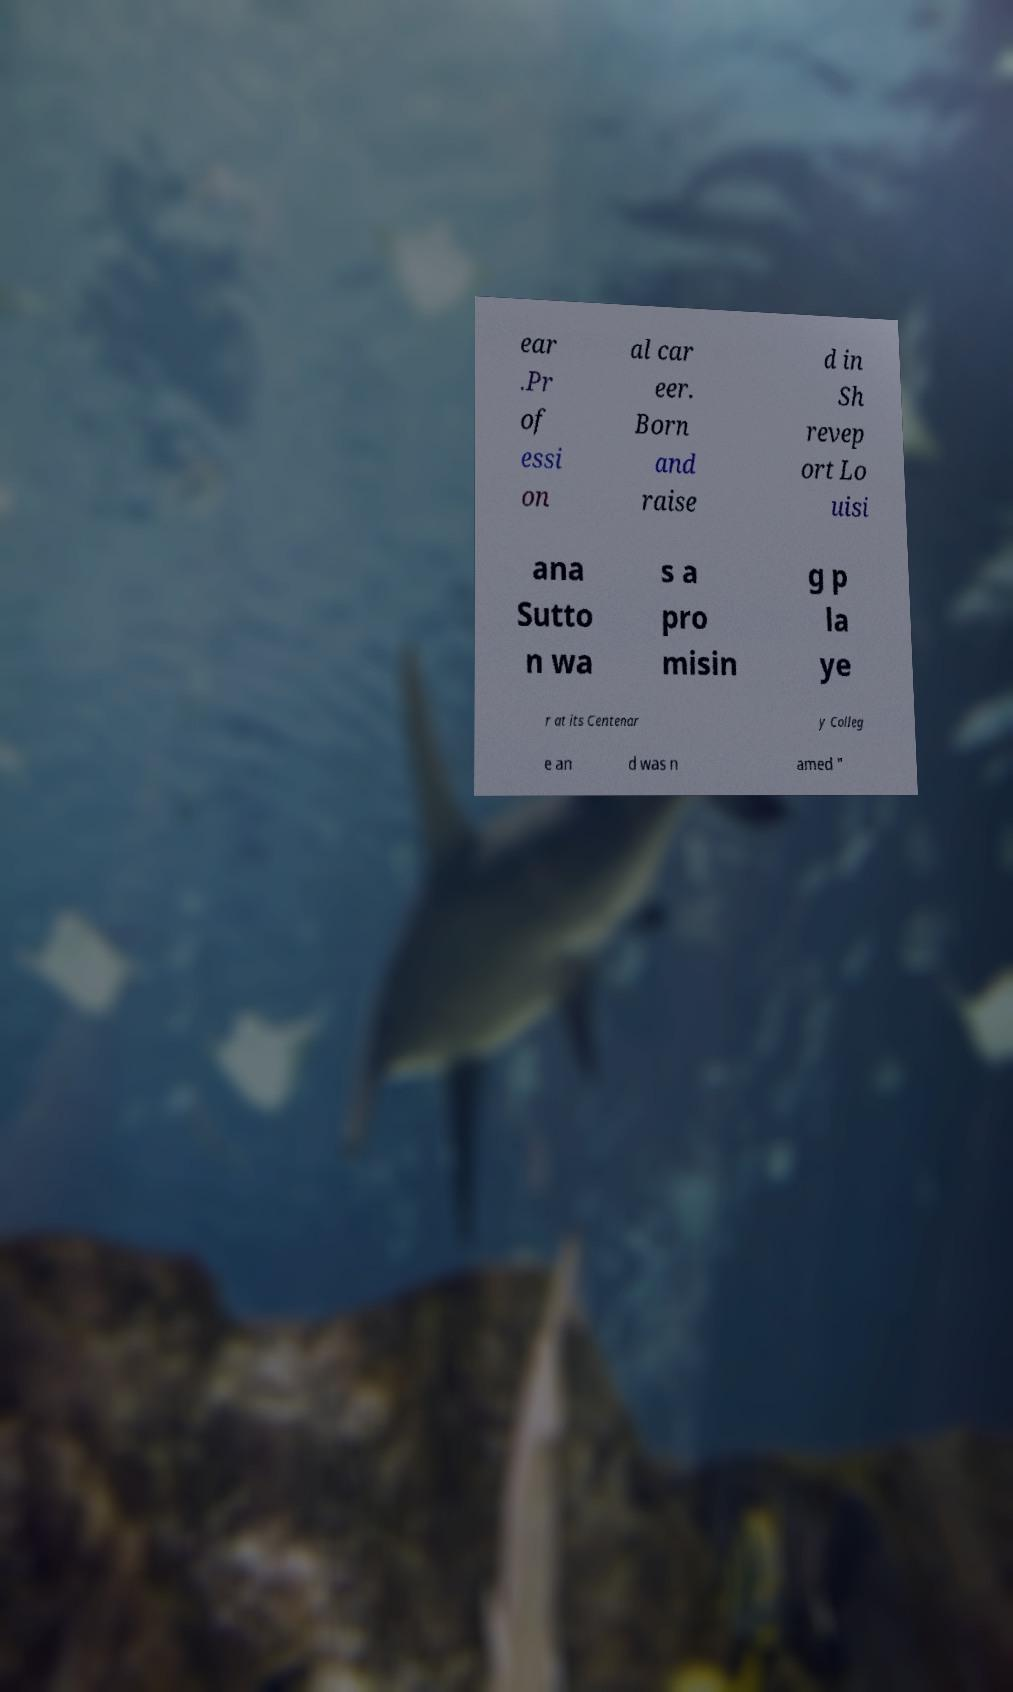Could you extract and type out the text from this image? ear .Pr of essi on al car eer. Born and raise d in Sh revep ort Lo uisi ana Sutto n wa s a pro misin g p la ye r at its Centenar y Colleg e an d was n amed " 